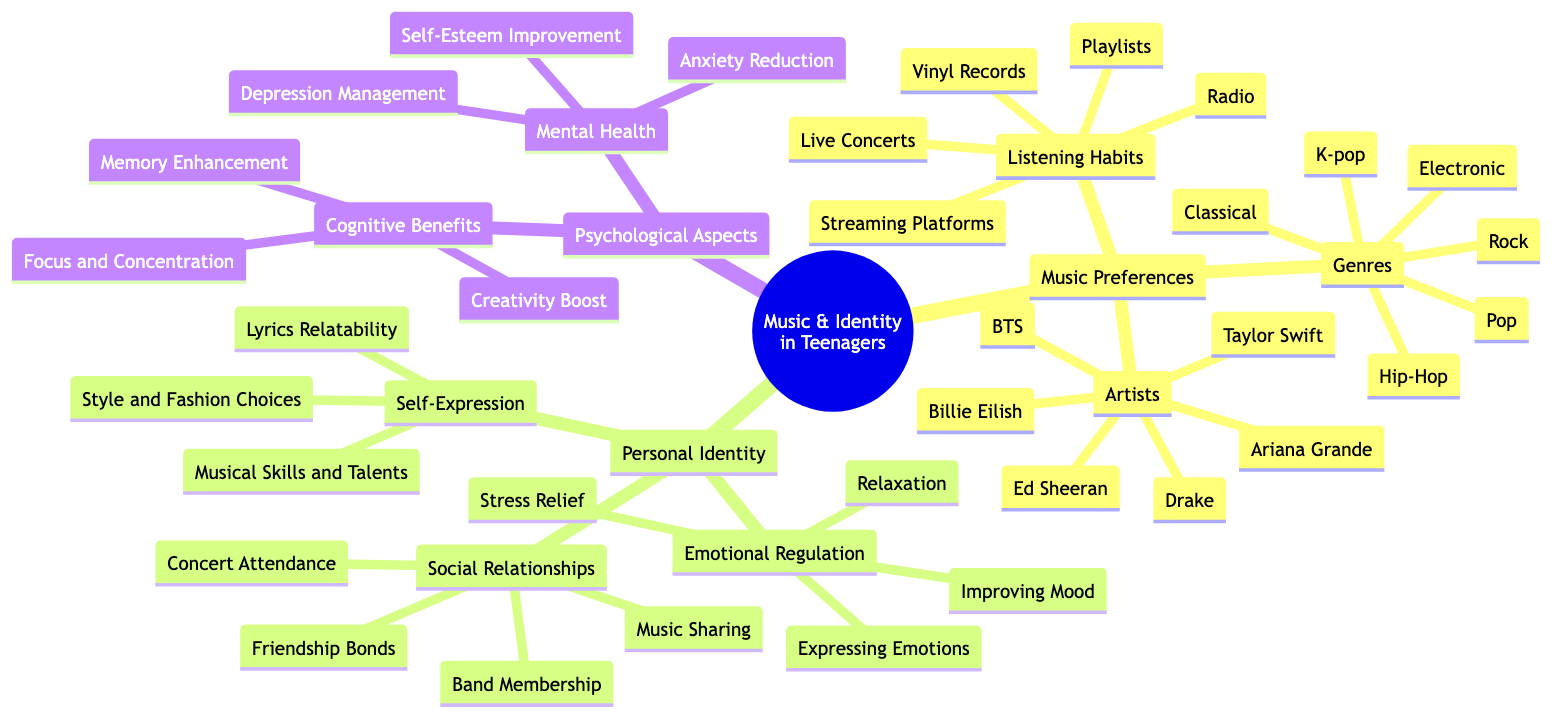What are the genres listed under Music Preferences? The diagram specifies several genres categorized under Music Preferences. The genres are Pop, Rock, Hip-Hop, Classical, Electronic, and K-pop.
Answer: Pop, Rock, Hip-Hop, Classical, Electronic, K-pop How many artists are mentioned in the diagram? Under the Artists subcategory, there are a total of six artists mentioned: Taylor Swift, BTS, Drake, Billie Eilish, Ed Sheeran, and Ariana Grande. Counting these gives a total of six.
Answer: 6 What is one aspect of Emotional Regulation mentioned? The diagram includes Emotional Regulation as a subcategory under Personal Identity. One of the listed items is Stress Relief, which is an aspect of how teenagers regulate their emotions through music.
Answer: Stress Relief Which two categories are linked by the concept of Self-Expression? Self-Expression is listed under Personal Identity and it connects to the overall concept of the relationship between Music Preferences and Personal Identity in Teenagers. From the context of the concept map, the two categories linked are Music Preferences and Personal Identity.
Answer: Music Preferences and Personal Identity How does music relate to Mental Health according to the diagram? The diagram shows that Mental Health is a subcategory of Psychological Aspects that lists several items including Anxiety Reduction, Depression Management, and Self-Esteem Improvement. This illustrates how music can positively impact mental health in teenagers.
Answer: Anxiety Reduction, Depression Management, Self-Esteem Improvement 